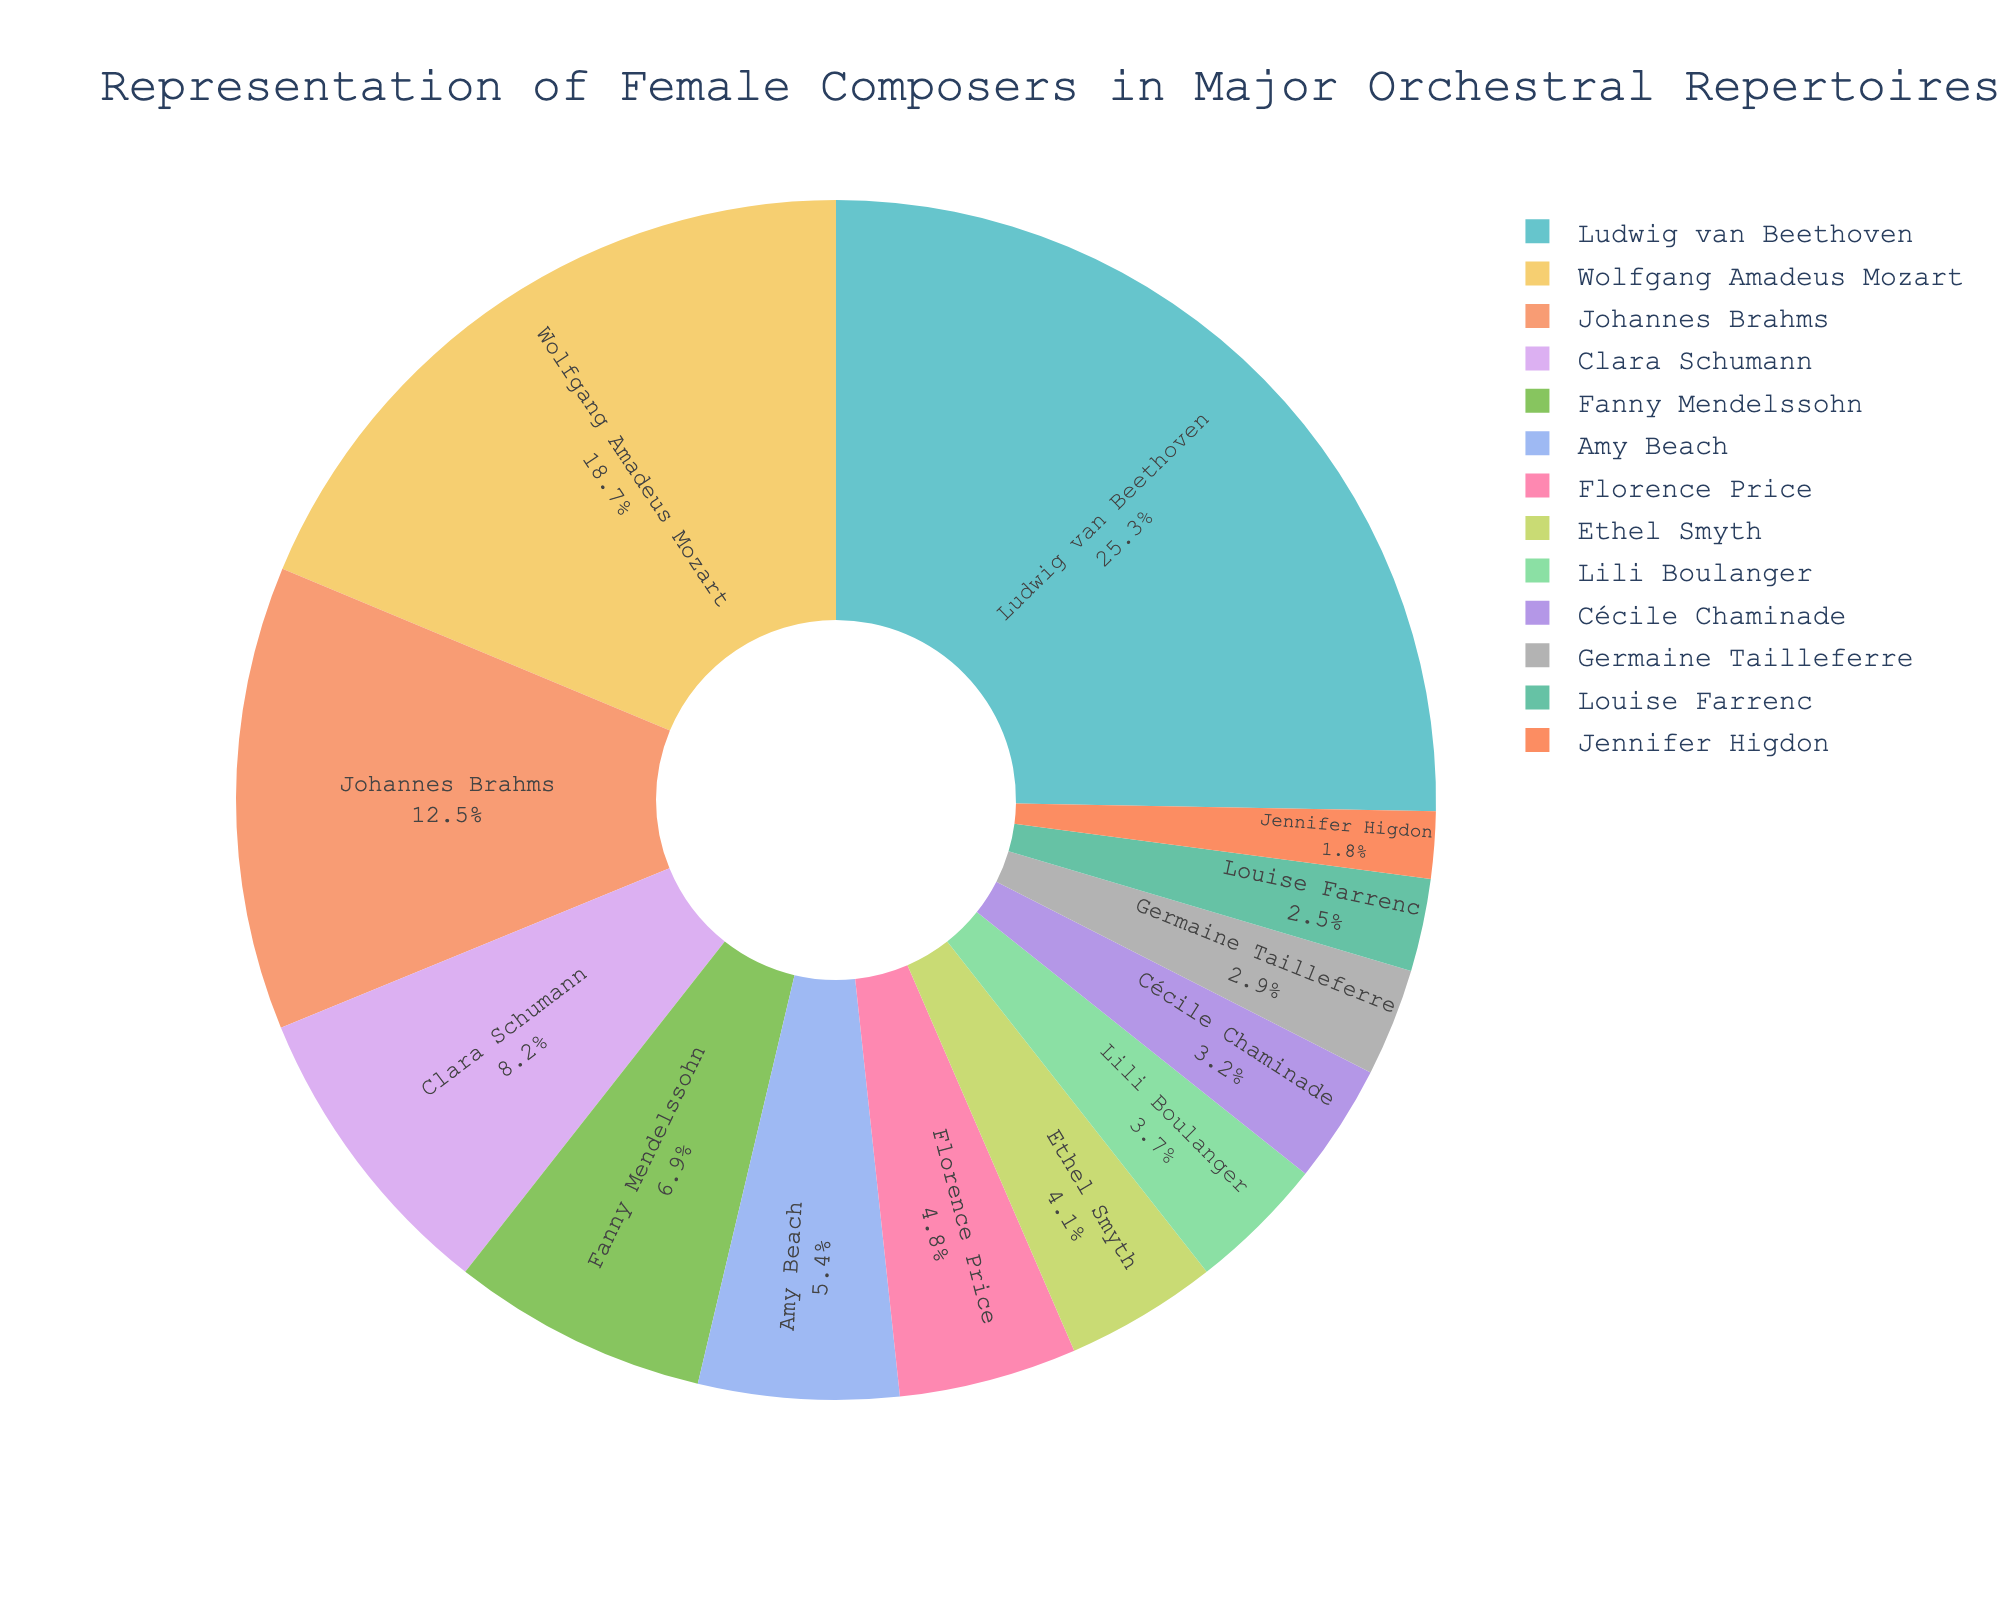What percentage of the total representation do Clara Schumann and Fanny Mendelssohn account for together? To find the combined percentage of Clara Schumann and Fanny Mendelssohn, add their individual percentages: 8.2 (Clara Schumann) + 6.9 (Fanny Mendelssohn) = 15.1
Answer: 15.1 Does Clara Schumann or Amy Beach have a higher representation in the major orchestral repertoires? Compare the percentages of Clara Schumann and Amy Beach: Clara Schumann has 8.2%, and Amy Beach has 5.4%.
Answer: Clara Schumann Which composer has the lowest representation according to the chart? Identify the composer with the smallest percentage. Jennifer Higdon has the lowest representation at 1.8%.
Answer: Jennifer Higdon What is the difference in representation between Wolfgang Amadeus Mozart and Florence Price? Subtract Florence Price's percentage from Wolfgang Amadeus Mozart's: 18.7 (Mozart) - 4.8 (Price) = 13.9
Answer: 13.9 How does the representation of Lili Boulanger compare to that of Ethel Smyth? Compare their percentages: Lili Boulanger has 3.7%, and Ethel Smyth has 4.1%.
Answer: Ethel Smyth has a higher percentage than Lili Boulanger Who are the top three composers in terms of representation? Identify the composers with the three highest percentages: Ludwig van Beethoven (25.3%), Wolfgang Amadeus Mozart (18.7%), Johannes Brahms (12.5%).
Answer: Ludwig van Beethoven, Wolfgang Amadeus Mozart, Johannes Brahms What combined percentage do the three composers with the least representation account for? Add the percentages of the three composers with the lowest representation: Germaine Tailleferre (2.9%), Louise Farrenc (2.5%), Jennifer Higdon (1.8%). The combined percentage is 2.9 + 2.5 + 1.8 = 7.2
Answer: 7.2 What is the visual difference between the slices representing Clara Schumann and Lili Boulanger in the pie chart? The slice representing Clara Schumann is larger because her percentage (8.2%) is greater than that of Lili Boulanger (3.7%). Additionally, the Clara Schumann slice may be visually highlighted by being slightly pulled out according to the code.
Answer: Clara Schumann's slice is larger How much more represented is the most represented composer compared to the composer with the median representation? First, determine the composer with the median representation by finding the middle value when the percentages are sorted: Cécile Chaminade with 3.2%. Then, subtract the median value from the highest value (Ludwig van Beethoven with 25.3%): 25.3 - 3.2 = 22.1
Answer: 22.1 What percentage of the total does Fanny Mendelssohn account for, and how does this rank among the female composers listed? Fanny Mendelssohn accounts for 6.9% of the total representation. To rank this among the female composers listed, we compare her percentage to the other female composers. The percentages of the female composers are Clara Schumann (8.2%), Amy Beach (5.4%), Florence Price (4.8%), Ethel Smyth (4.1%), Lili Boulanger (3.7%), Cécile Chaminade (3.2%), Germaine Tailleferre (2.9%), Louise Farrenc (2.5%), and Jennifer Higdon (1.8%). Fanny Mendelssohn ranks second among the female composers in terms of representation.
Answer: 6.9%, second 